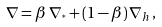<formula> <loc_0><loc_0><loc_500><loc_500>\nabla = \beta \, \nabla _ { ^ { * } } + ( 1 - \beta ) \, \nabla _ { h } \, ,</formula> 